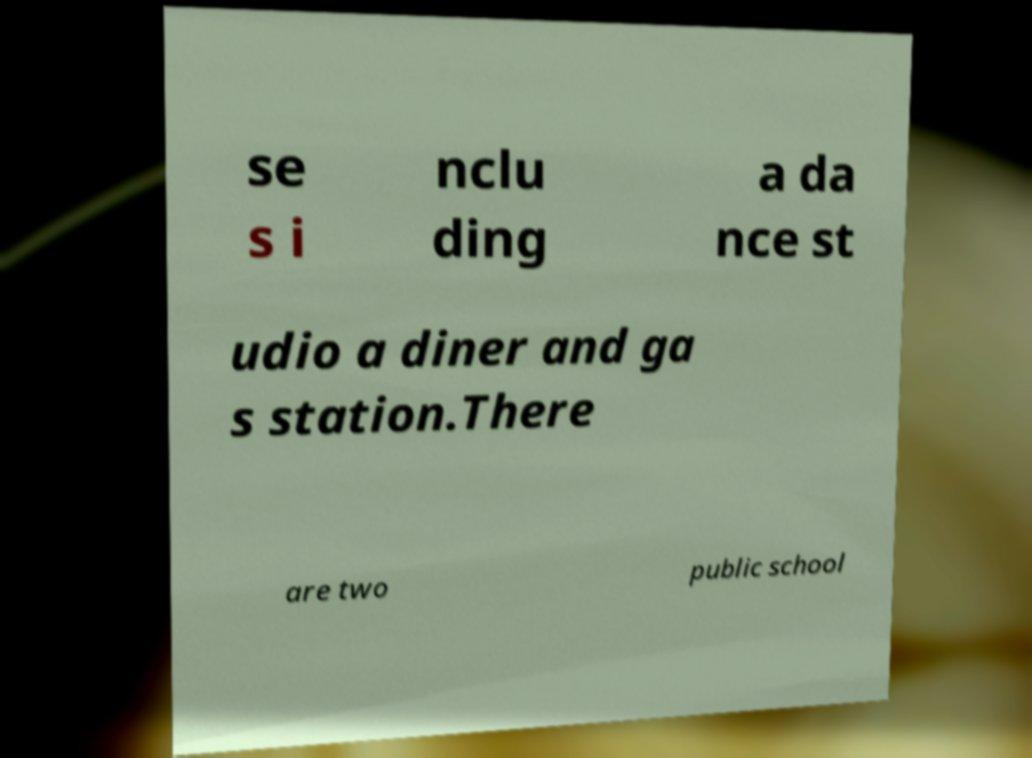Please identify and transcribe the text found in this image. se s i nclu ding a da nce st udio a diner and ga s station.There are two public school 